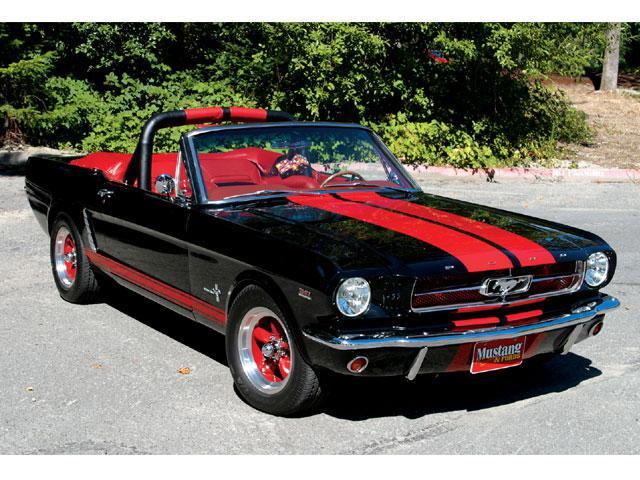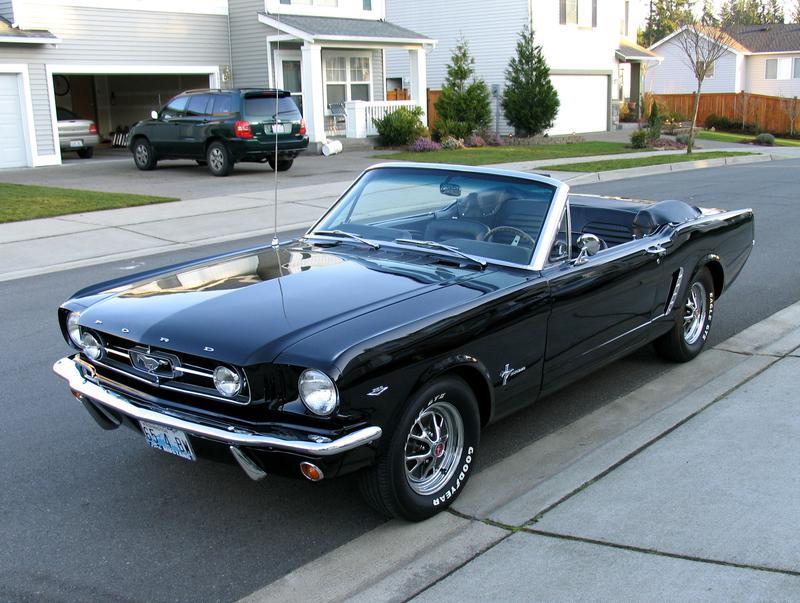The first image is the image on the left, the second image is the image on the right. Evaluate the accuracy of this statement regarding the images: "There is a car whose main body color is red.". Is it true? Answer yes or no. No. 